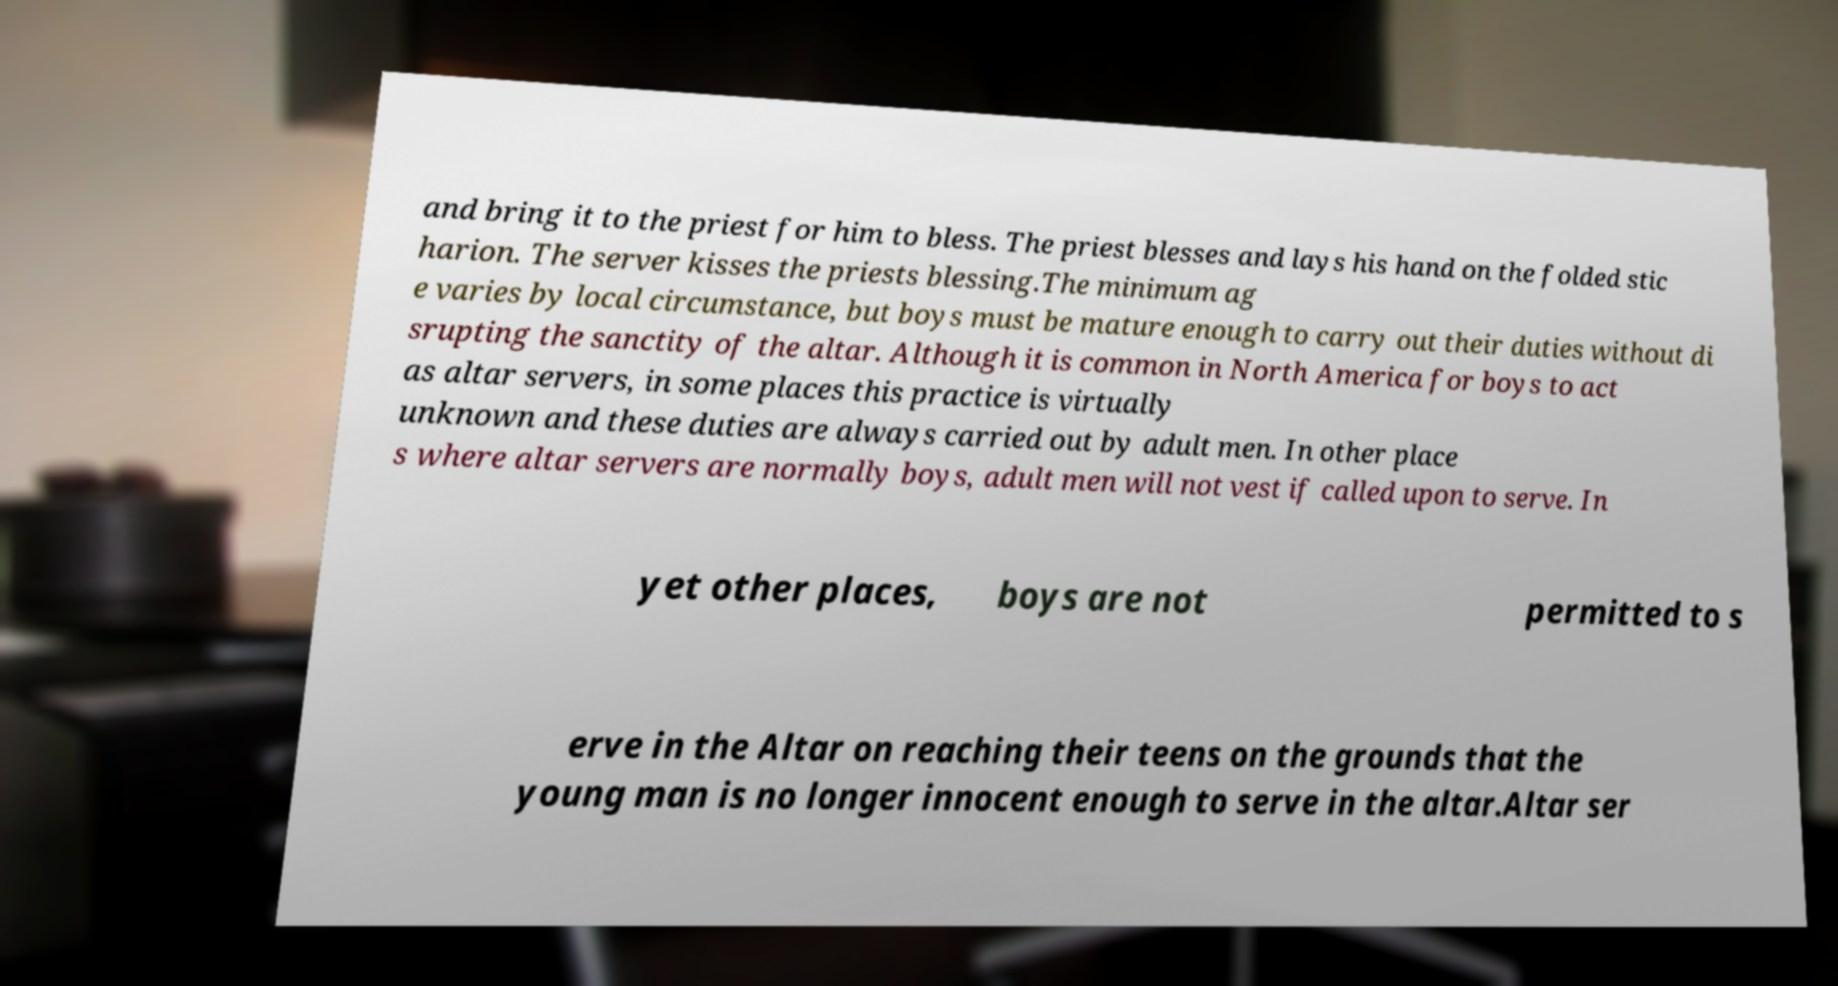For documentation purposes, I need the text within this image transcribed. Could you provide that? and bring it to the priest for him to bless. The priest blesses and lays his hand on the folded stic harion. The server kisses the priests blessing.The minimum ag e varies by local circumstance, but boys must be mature enough to carry out their duties without di srupting the sanctity of the altar. Although it is common in North America for boys to act as altar servers, in some places this practice is virtually unknown and these duties are always carried out by adult men. In other place s where altar servers are normally boys, adult men will not vest if called upon to serve. In yet other places, boys are not permitted to s erve in the Altar on reaching their teens on the grounds that the young man is no longer innocent enough to serve in the altar.Altar ser 